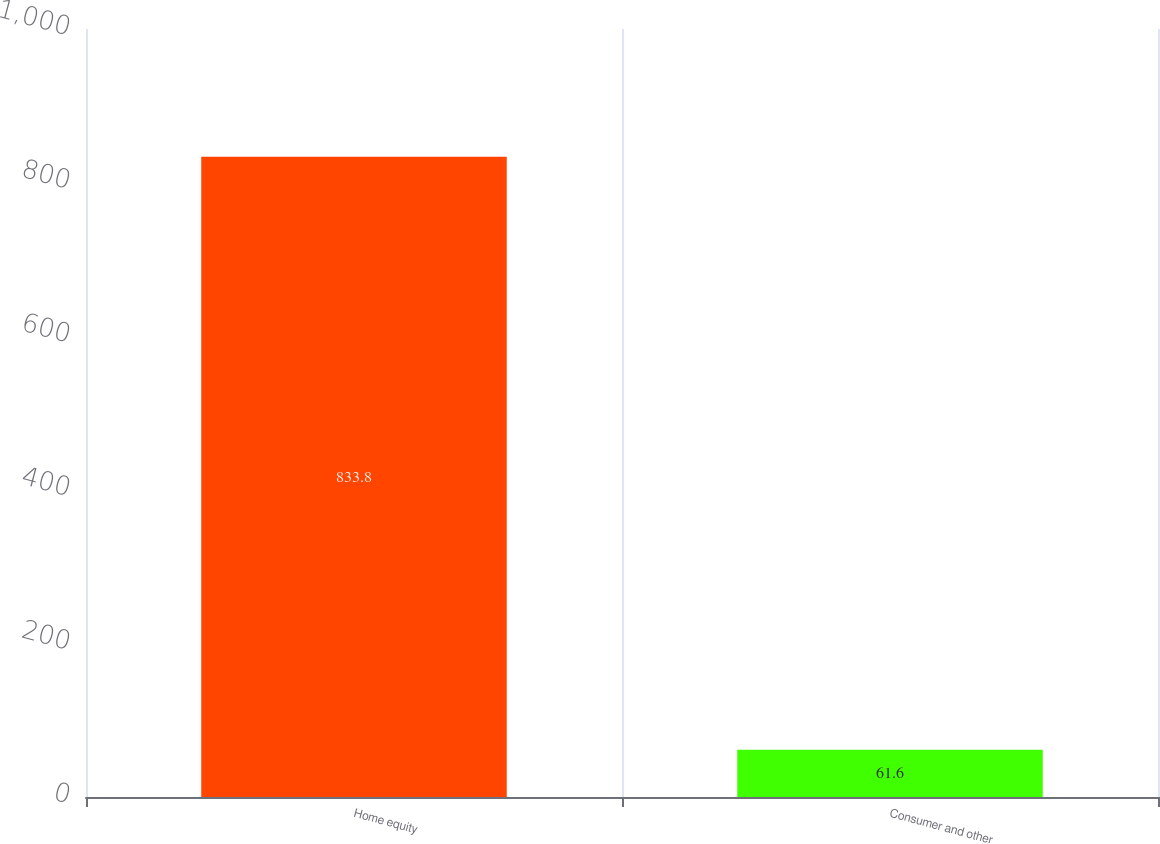Convert chart to OTSL. <chart><loc_0><loc_0><loc_500><loc_500><bar_chart><fcel>Home equity<fcel>Consumer and other<nl><fcel>833.8<fcel>61.6<nl></chart> 